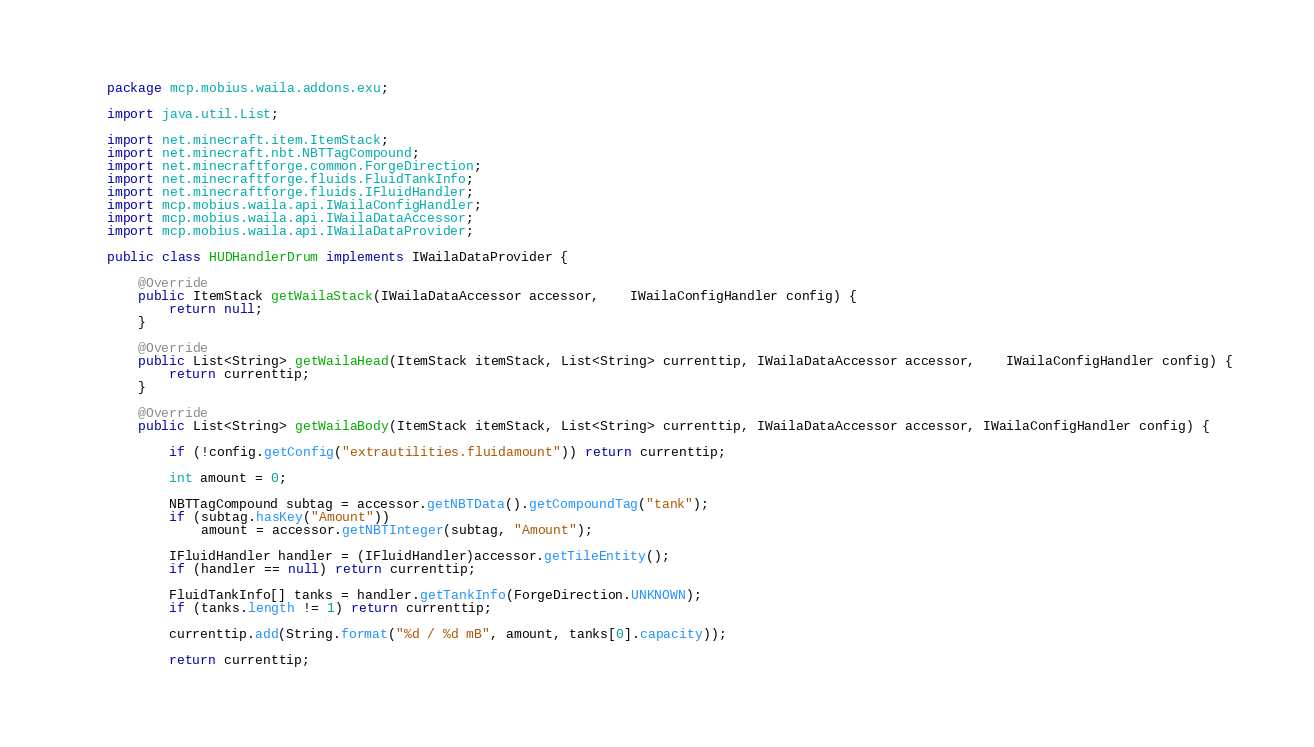<code> <loc_0><loc_0><loc_500><loc_500><_Java_>package mcp.mobius.waila.addons.exu;

import java.util.List;

import net.minecraft.item.ItemStack;
import net.minecraft.nbt.NBTTagCompound;
import net.minecraftforge.common.ForgeDirection;
import net.minecraftforge.fluids.FluidTankInfo;
import net.minecraftforge.fluids.IFluidHandler;
import mcp.mobius.waila.api.IWailaConfigHandler;
import mcp.mobius.waila.api.IWailaDataAccessor;
import mcp.mobius.waila.api.IWailaDataProvider;

public class HUDHandlerDrum implements IWailaDataProvider {

	@Override
	public ItemStack getWailaStack(IWailaDataAccessor accessor,	IWailaConfigHandler config) {
		return null;
	}

	@Override
	public List<String> getWailaHead(ItemStack itemStack, List<String> currenttip, IWailaDataAccessor accessor,	IWailaConfigHandler config) {
		return currenttip;
	}

	@Override
	public List<String> getWailaBody(ItemStack itemStack, List<String> currenttip, IWailaDataAccessor accessor, IWailaConfigHandler config) {
		
		if (!config.getConfig("extrautilities.fluidamount")) return currenttip;
		
		int amount = 0;
		
		NBTTagCompound subtag = accessor.getNBTData().getCompoundTag("tank");
		if (subtag.hasKey("Amount"))
			amount = accessor.getNBTInteger(subtag, "Amount");
		
		IFluidHandler handler = (IFluidHandler)accessor.getTileEntity();
		if (handler == null) return currenttip;
		
		FluidTankInfo[] tanks = handler.getTankInfo(ForgeDirection.UNKNOWN);
		if (tanks.length != 1) return currenttip;
		
		currenttip.add(String.format("%d / %d mB", amount, tanks[0].capacity));
		
		return currenttip;</code> 